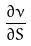<formula> <loc_0><loc_0><loc_500><loc_500>\frac { \partial \nu } { \partial S }</formula> 